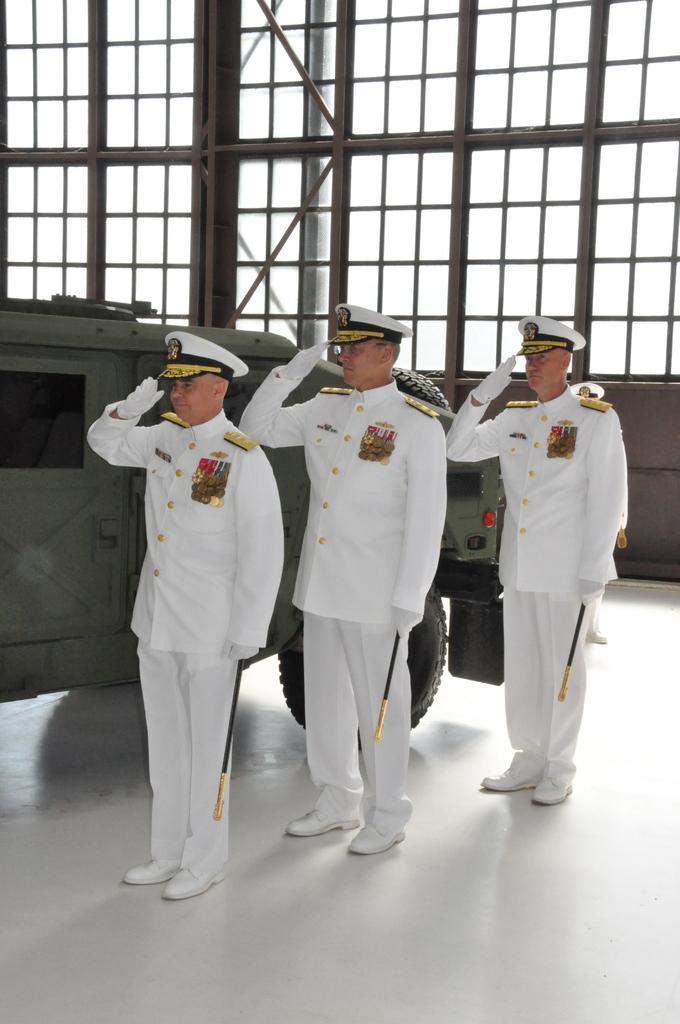In one or two sentences, can you explain what this image depicts? In this picture we can see three men wore caps and standing on the floor and holding sticks with their hands, vehicle and at the back of them we can see windows. 